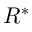Convert formula to latex. <formula><loc_0><loc_0><loc_500><loc_500>R ^ { * }</formula> 